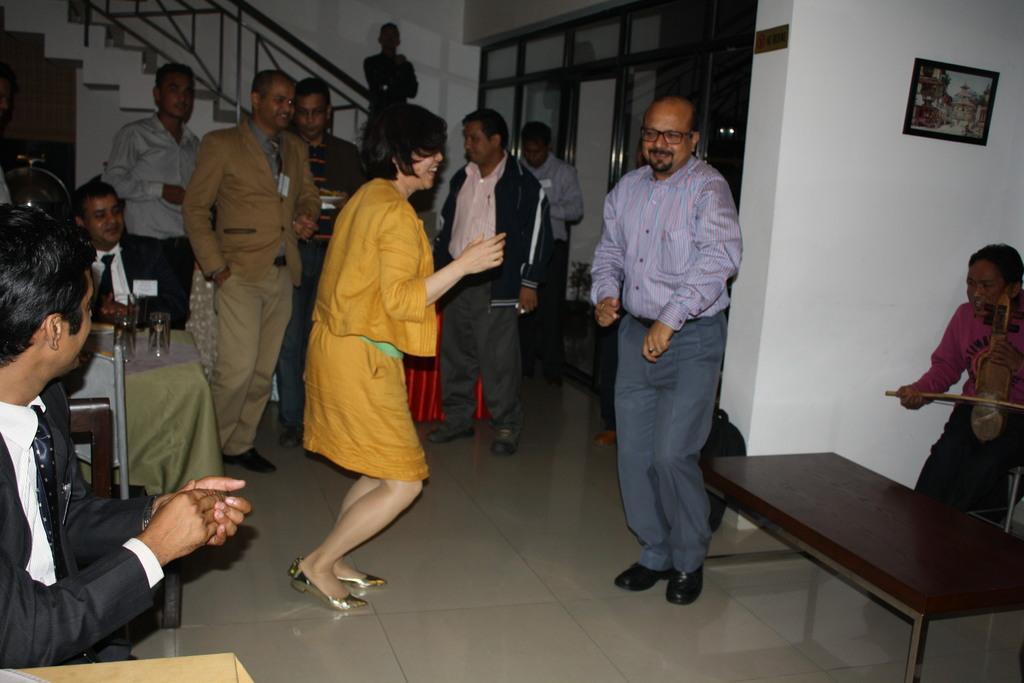Could you give a brief overview of what you see in this image? In this image I can see number of people are standing. I can also see few tables and chairs. 